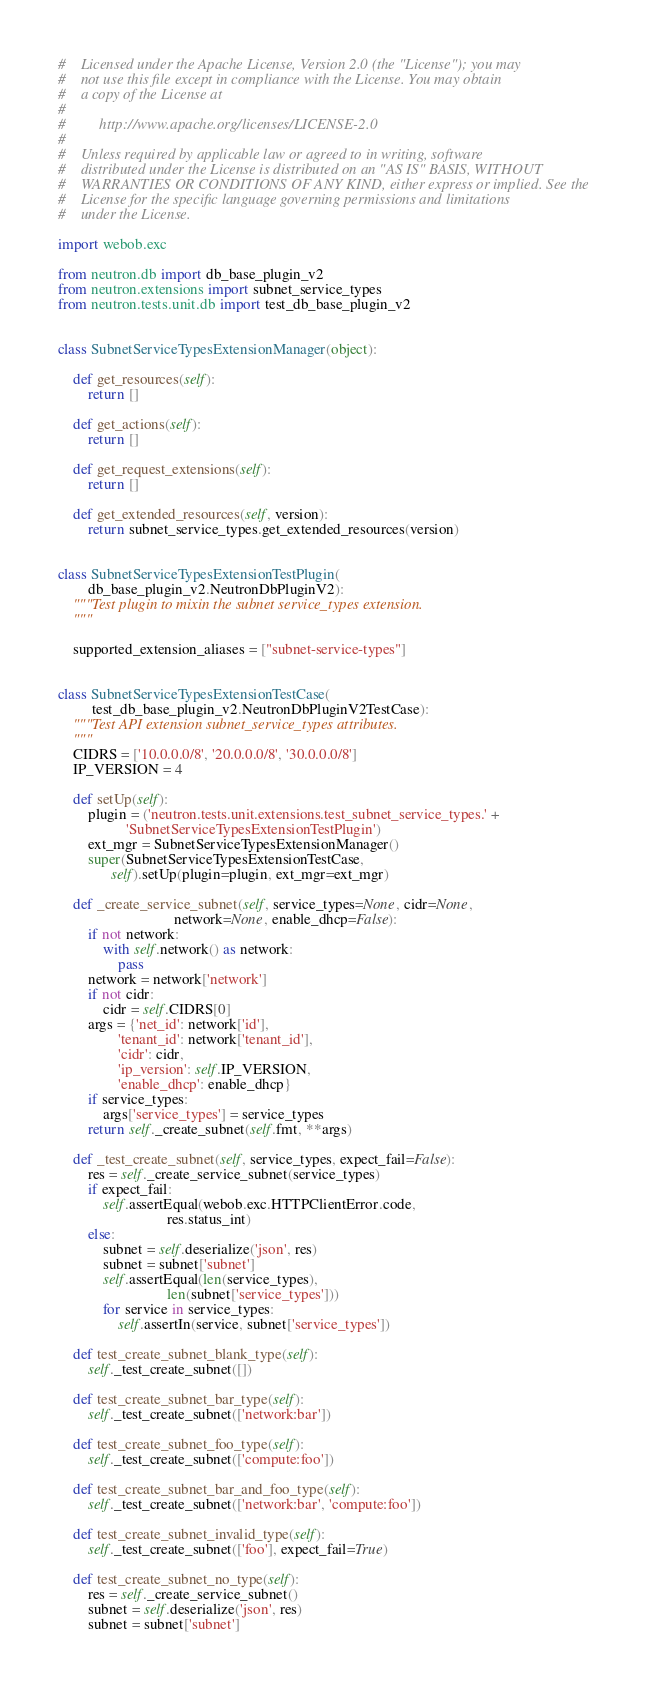<code> <loc_0><loc_0><loc_500><loc_500><_Python_>#    Licensed under the Apache License, Version 2.0 (the "License"); you may
#    not use this file except in compliance with the License. You may obtain
#    a copy of the License at
#
#         http://www.apache.org/licenses/LICENSE-2.0
#
#    Unless required by applicable law or agreed to in writing, software
#    distributed under the License is distributed on an "AS IS" BASIS, WITHOUT
#    WARRANTIES OR CONDITIONS OF ANY KIND, either express or implied. See the
#    License for the specific language governing permissions and limitations
#    under the License.

import webob.exc

from neutron.db import db_base_plugin_v2
from neutron.extensions import subnet_service_types
from neutron.tests.unit.db import test_db_base_plugin_v2


class SubnetServiceTypesExtensionManager(object):

    def get_resources(self):
        return []

    def get_actions(self):
        return []

    def get_request_extensions(self):
        return []

    def get_extended_resources(self, version):
        return subnet_service_types.get_extended_resources(version)


class SubnetServiceTypesExtensionTestPlugin(
        db_base_plugin_v2.NeutronDbPluginV2):
    """Test plugin to mixin the subnet service_types extension.
    """

    supported_extension_aliases = ["subnet-service-types"]


class SubnetServiceTypesExtensionTestCase(
         test_db_base_plugin_v2.NeutronDbPluginV2TestCase):
    """Test API extension subnet_service_types attributes.
    """
    CIDRS = ['10.0.0.0/8', '20.0.0.0/8', '30.0.0.0/8']
    IP_VERSION = 4

    def setUp(self):
        plugin = ('neutron.tests.unit.extensions.test_subnet_service_types.' +
                  'SubnetServiceTypesExtensionTestPlugin')
        ext_mgr = SubnetServiceTypesExtensionManager()
        super(SubnetServiceTypesExtensionTestCase,
              self).setUp(plugin=plugin, ext_mgr=ext_mgr)

    def _create_service_subnet(self, service_types=None, cidr=None,
                               network=None, enable_dhcp=False):
        if not network:
            with self.network() as network:
                pass
        network = network['network']
        if not cidr:
            cidr = self.CIDRS[0]
        args = {'net_id': network['id'],
                'tenant_id': network['tenant_id'],
                'cidr': cidr,
                'ip_version': self.IP_VERSION,
                'enable_dhcp': enable_dhcp}
        if service_types:
            args['service_types'] = service_types
        return self._create_subnet(self.fmt, **args)

    def _test_create_subnet(self, service_types, expect_fail=False):
        res = self._create_service_subnet(service_types)
        if expect_fail:
            self.assertEqual(webob.exc.HTTPClientError.code,
                             res.status_int)
        else:
            subnet = self.deserialize('json', res)
            subnet = subnet['subnet']
            self.assertEqual(len(service_types),
                             len(subnet['service_types']))
            for service in service_types:
                self.assertIn(service, subnet['service_types'])

    def test_create_subnet_blank_type(self):
        self._test_create_subnet([])

    def test_create_subnet_bar_type(self):
        self._test_create_subnet(['network:bar'])

    def test_create_subnet_foo_type(self):
        self._test_create_subnet(['compute:foo'])

    def test_create_subnet_bar_and_foo_type(self):
        self._test_create_subnet(['network:bar', 'compute:foo'])

    def test_create_subnet_invalid_type(self):
        self._test_create_subnet(['foo'], expect_fail=True)

    def test_create_subnet_no_type(self):
        res = self._create_service_subnet()
        subnet = self.deserialize('json', res)
        subnet = subnet['subnet']</code> 